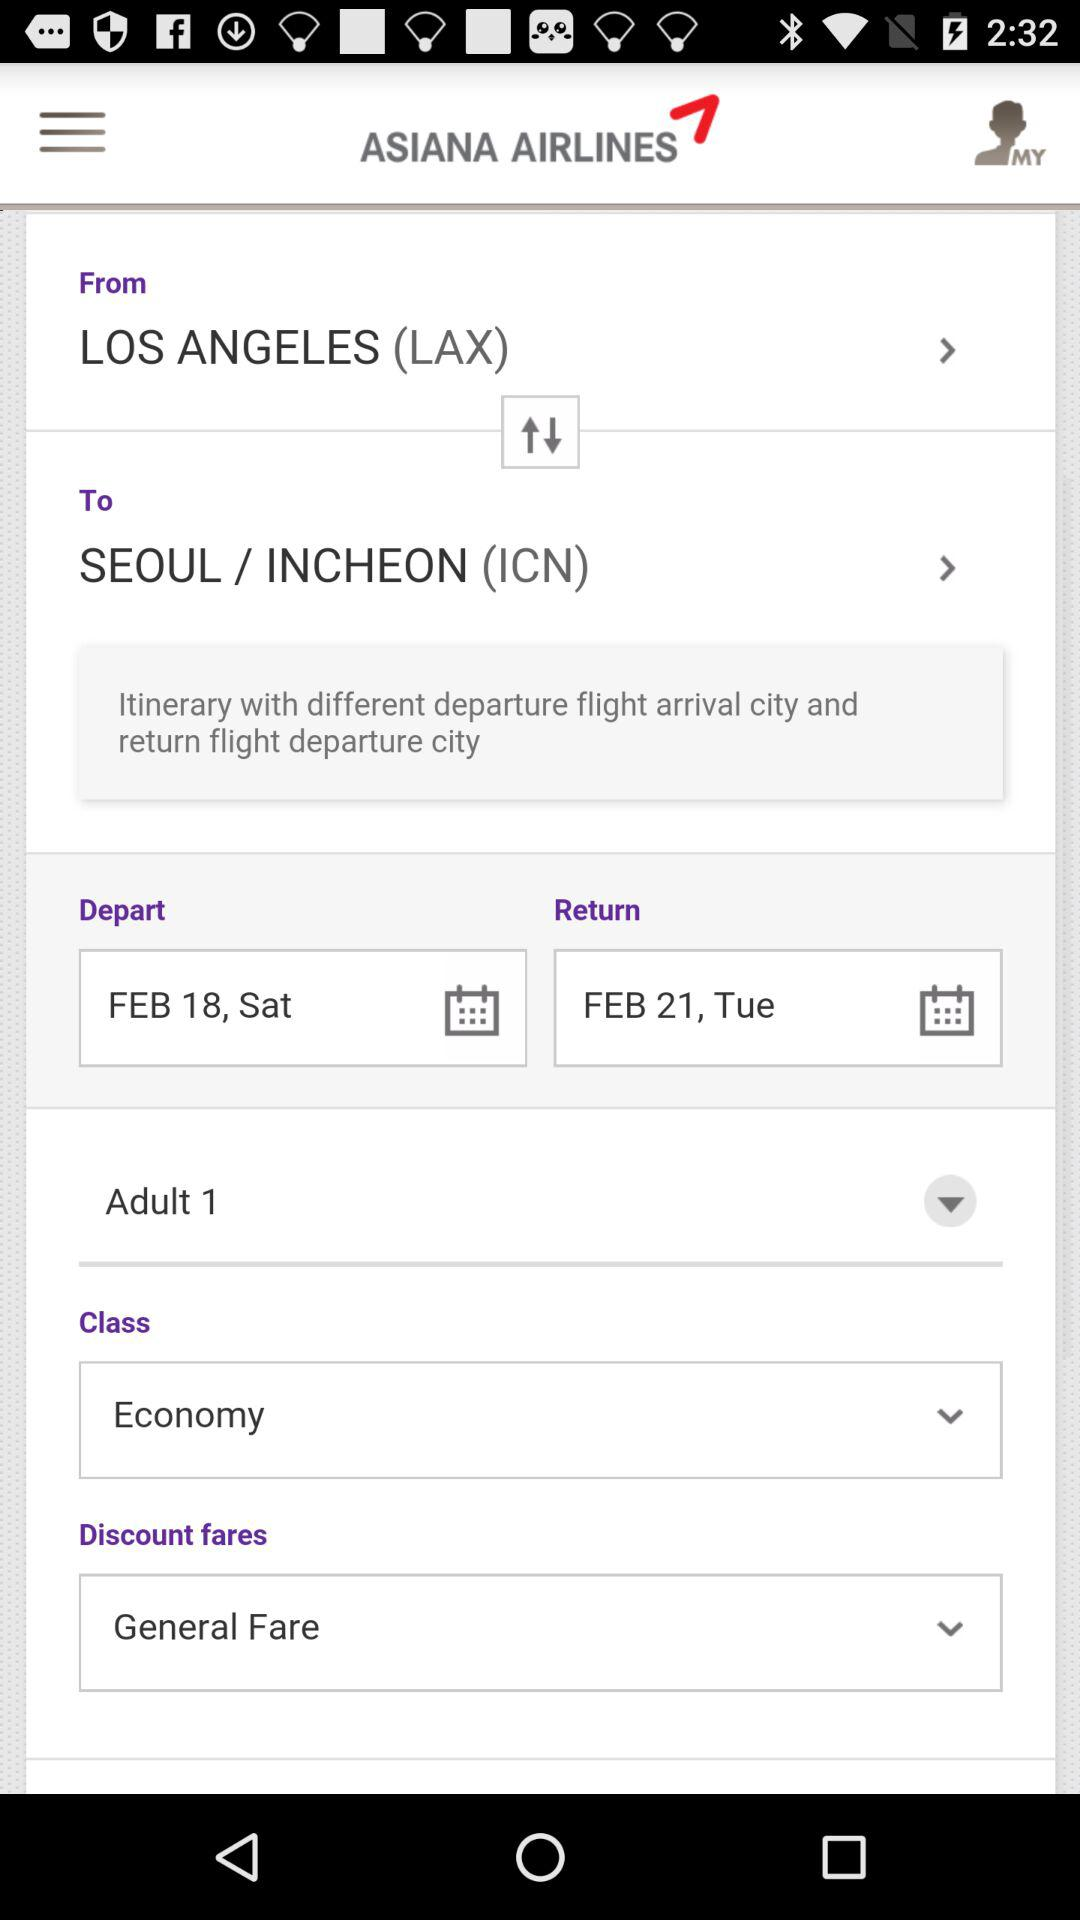What is the option for "Discount fares"? The option is "General Fare". 